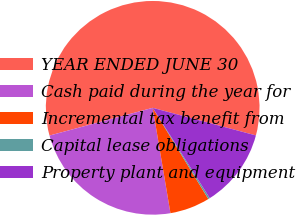Convert chart. <chart><loc_0><loc_0><loc_500><loc_500><pie_chart><fcel>YEAR ENDED JUNE 30<fcel>Cash paid during the year for<fcel>Incremental tax benefit from<fcel>Capital lease obligations<fcel>Property plant and equipment<nl><fcel>58.33%<fcel>23.48%<fcel>6.06%<fcel>0.25%<fcel>11.87%<nl></chart> 